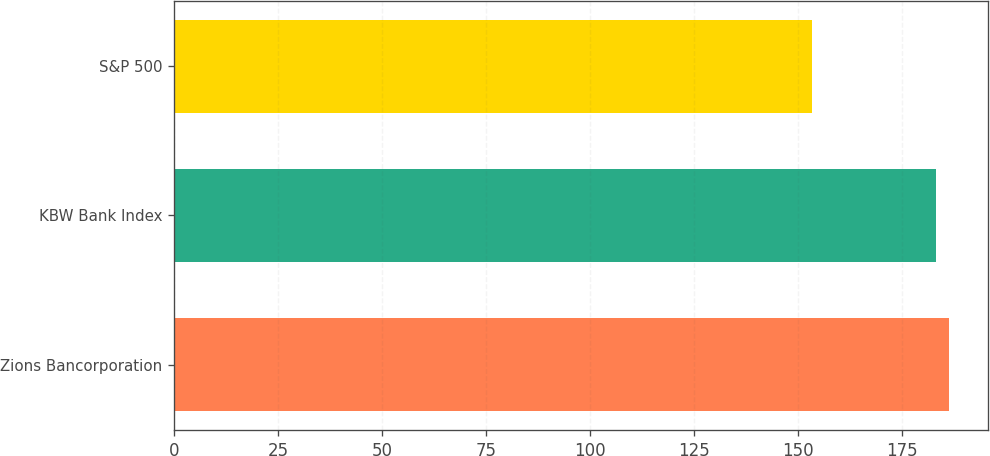Convert chart to OTSL. <chart><loc_0><loc_0><loc_500><loc_500><bar_chart><fcel>Zions Bancorporation<fcel>KBW Bank Index<fcel>S&P 500<nl><fcel>186.48<fcel>183.3<fcel>153.5<nl></chart> 